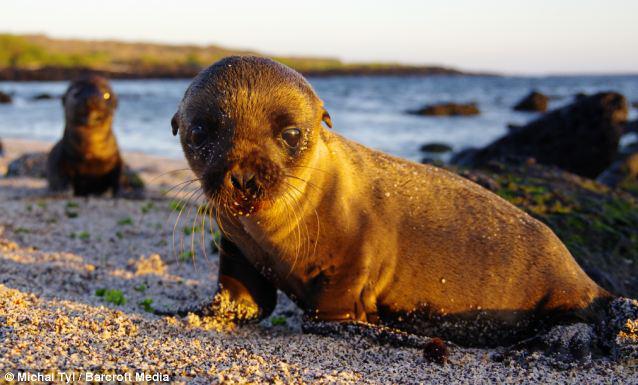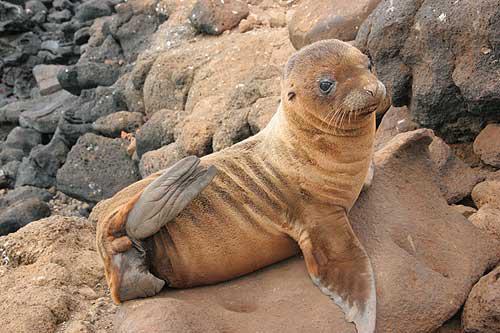The first image is the image on the left, the second image is the image on the right. Assess this claim about the two images: "Two seals are on a sandy surface in the image on the left.". Correct or not? Answer yes or no. Yes. 